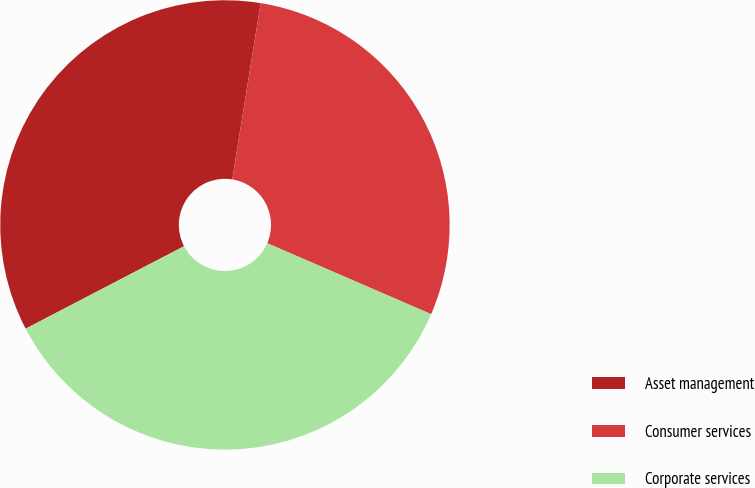Convert chart to OTSL. <chart><loc_0><loc_0><loc_500><loc_500><pie_chart><fcel>Asset management<fcel>Consumer services<fcel>Corporate services<nl><fcel>35.19%<fcel>28.96%<fcel>35.86%<nl></chart> 